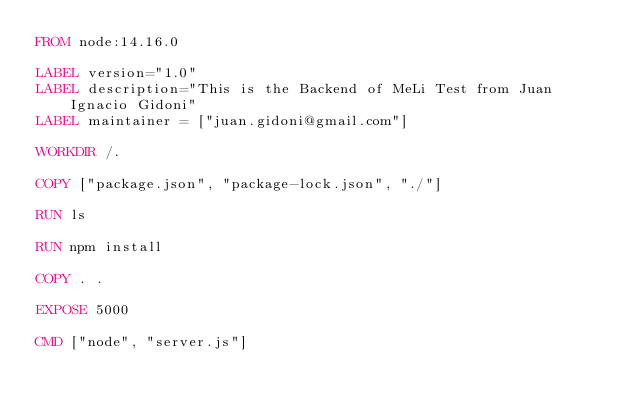<code> <loc_0><loc_0><loc_500><loc_500><_Dockerfile_>FROM node:14.16.0

LABEL version="1.0"
LABEL description="This is the Backend of MeLi Test from Juan Ignacio Gidoni"
LABEL maintainer = ["juan.gidoni@gmail.com"]

WORKDIR /.

COPY ["package.json", "package-lock.json", "./"]

RUN ls

RUN npm install

COPY . .

EXPOSE 5000

CMD ["node", "server.js"]</code> 